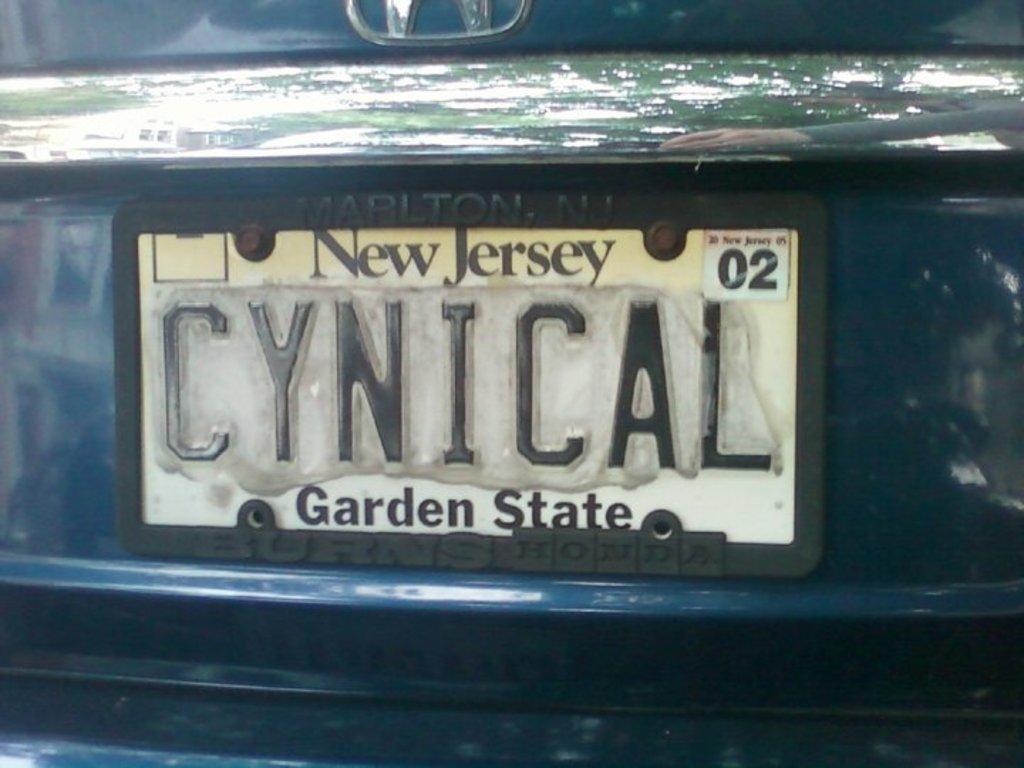State of new jersey?
Offer a very short reply. Yes. 